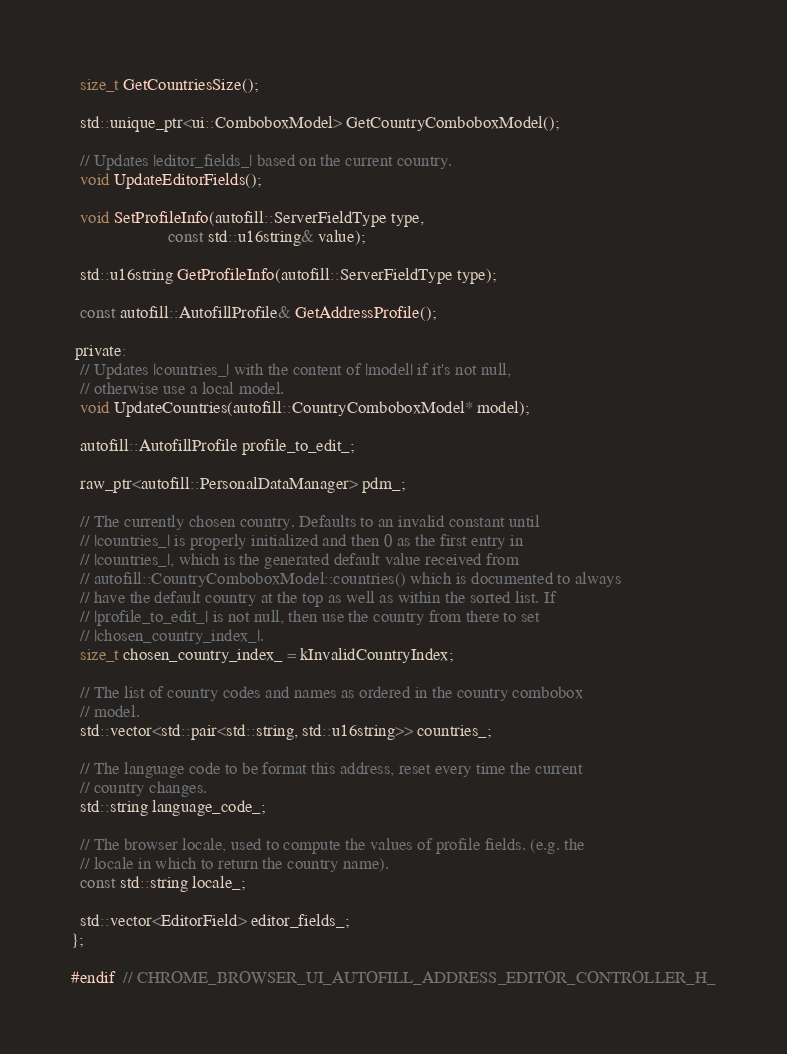<code> <loc_0><loc_0><loc_500><loc_500><_C_>
  size_t GetCountriesSize();

  std::unique_ptr<ui::ComboboxModel> GetCountryComboboxModel();

  // Updates |editor_fields_| based on the current country.
  void UpdateEditorFields();

  void SetProfileInfo(autofill::ServerFieldType type,
                      const std::u16string& value);

  std::u16string GetProfileInfo(autofill::ServerFieldType type);

  const autofill::AutofillProfile& GetAddressProfile();

 private:
  // Updates |countries_| with the content of |model| if it's not null,
  // otherwise use a local model.
  void UpdateCountries(autofill::CountryComboboxModel* model);

  autofill::AutofillProfile profile_to_edit_;

  raw_ptr<autofill::PersonalDataManager> pdm_;

  // The currently chosen country. Defaults to an invalid constant until
  // |countries_| is properly initialized and then 0 as the first entry in
  // |countries_|, which is the generated default value received from
  // autofill::CountryComboboxModel::countries() which is documented to always
  // have the default country at the top as well as within the sorted list. If
  // |profile_to_edit_| is not null, then use the country from there to set
  // |chosen_country_index_|.
  size_t chosen_country_index_ = kInvalidCountryIndex;

  // The list of country codes and names as ordered in the country combobox
  // model.
  std::vector<std::pair<std::string, std::u16string>> countries_;

  // The language code to be format this address, reset every time the current
  // country changes.
  std::string language_code_;

  // The browser locale, used to compute the values of profile fields. (e.g. the
  // locale in which to return the country name).
  const std::string locale_;

  std::vector<EditorField> editor_fields_;
};

#endif  // CHROME_BROWSER_UI_AUTOFILL_ADDRESS_EDITOR_CONTROLLER_H_
</code> 